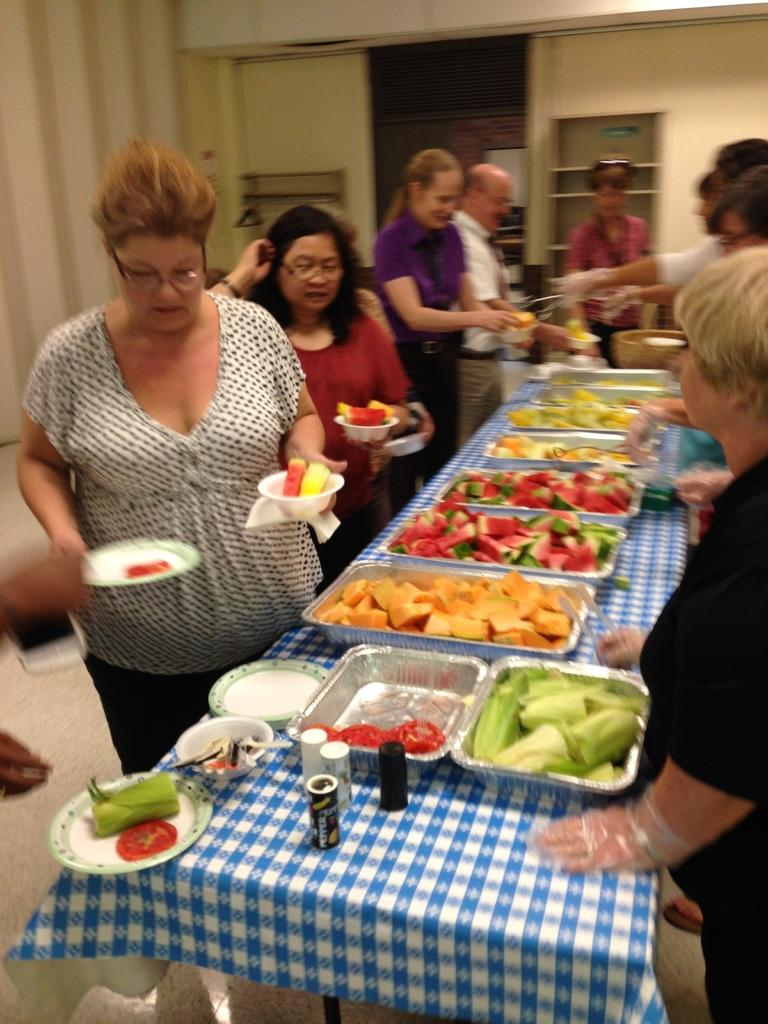How many people are in the image? There is a group of persons in the image. What are the persons doing in the image? The persons are standing around a table. What can be seen on the table? There are food items on the table. What is visible in the background of the image? There is a wall visible in the background of the image. How many pizzas are hanging from the icicle in the image? There is no icicle or pizza present in the image. 